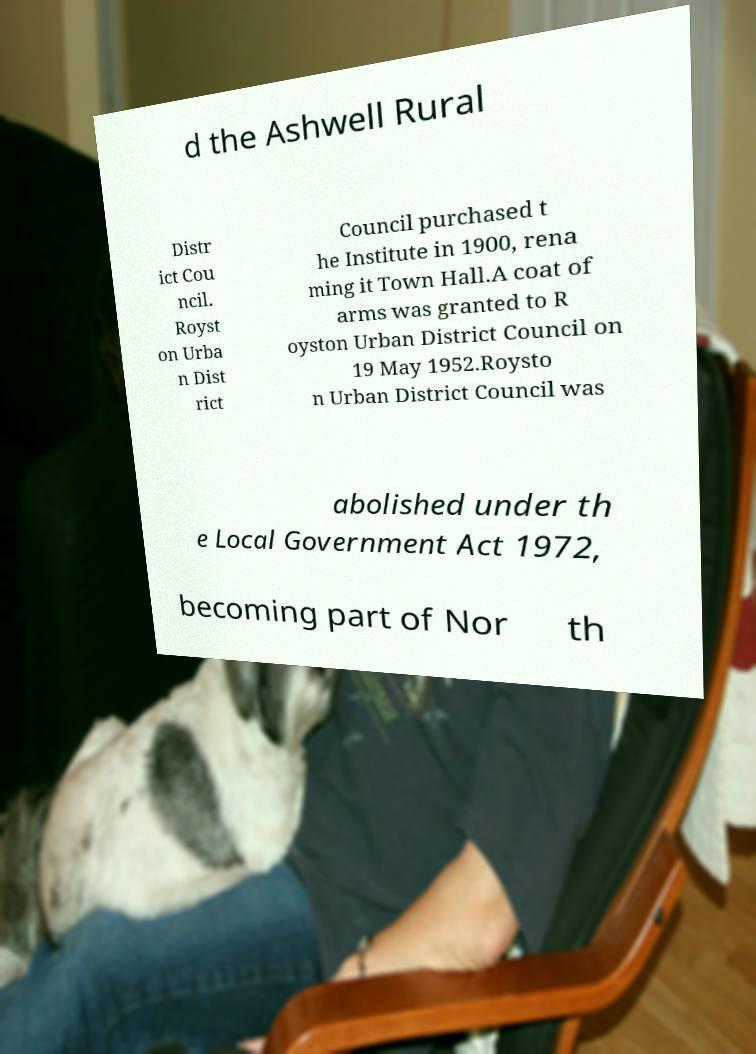What messages or text are displayed in this image? I need them in a readable, typed format. d the Ashwell Rural Distr ict Cou ncil. Royst on Urba n Dist rict Council purchased t he Institute in 1900, rena ming it Town Hall.A coat of arms was granted to R oyston Urban District Council on 19 May 1952.Roysto n Urban District Council was abolished under th e Local Government Act 1972, becoming part of Nor th 